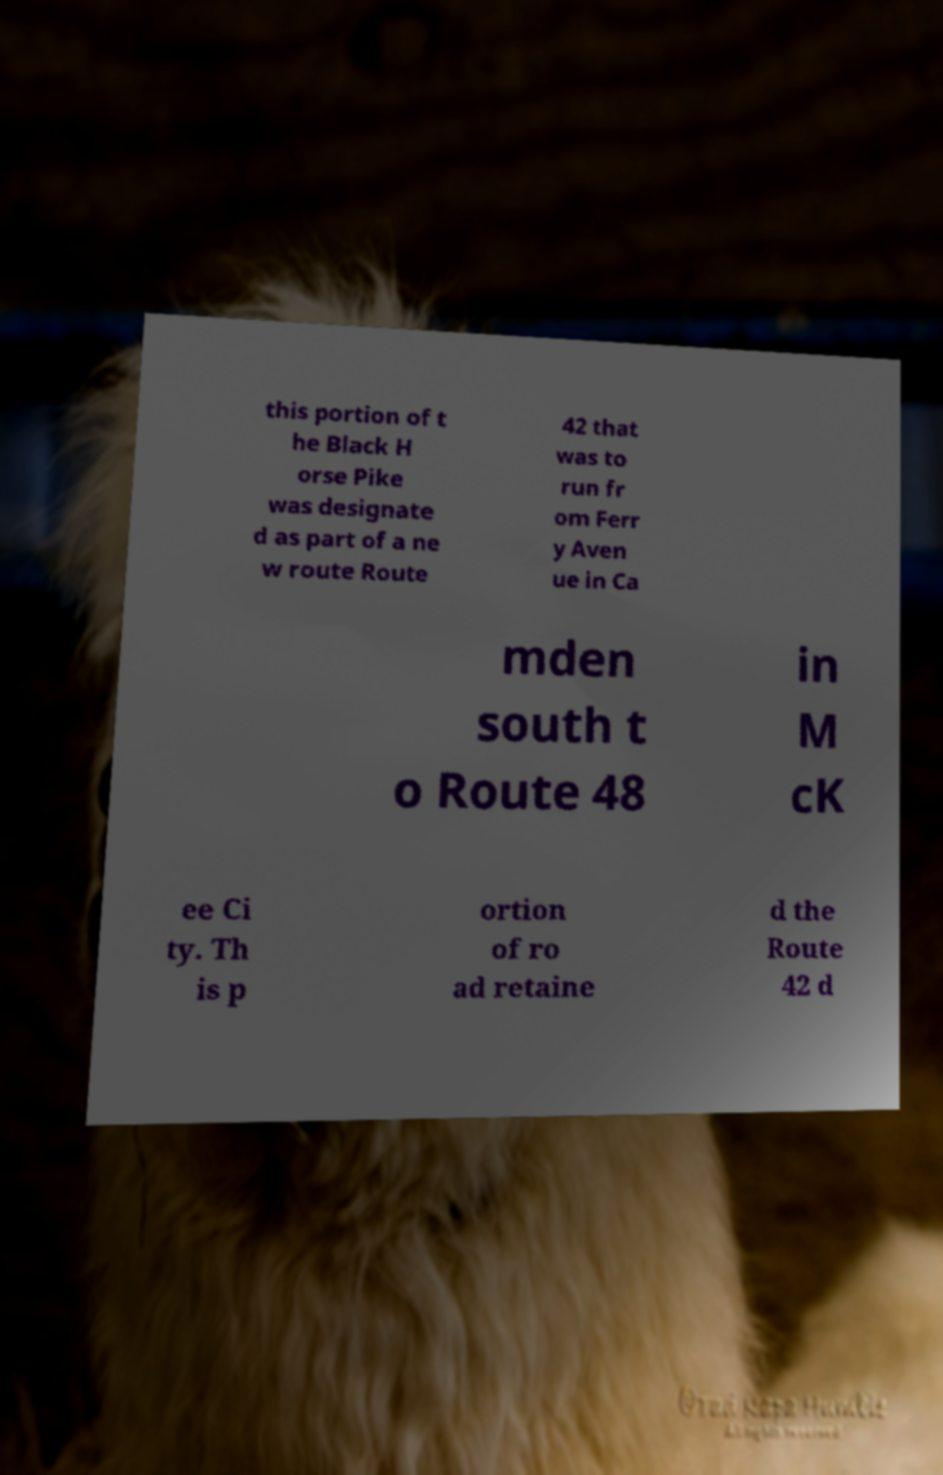Please identify and transcribe the text found in this image. this portion of t he Black H orse Pike was designate d as part of a ne w route Route 42 that was to run fr om Ferr y Aven ue in Ca mden south t o Route 48 in M cK ee Ci ty. Th is p ortion of ro ad retaine d the Route 42 d 